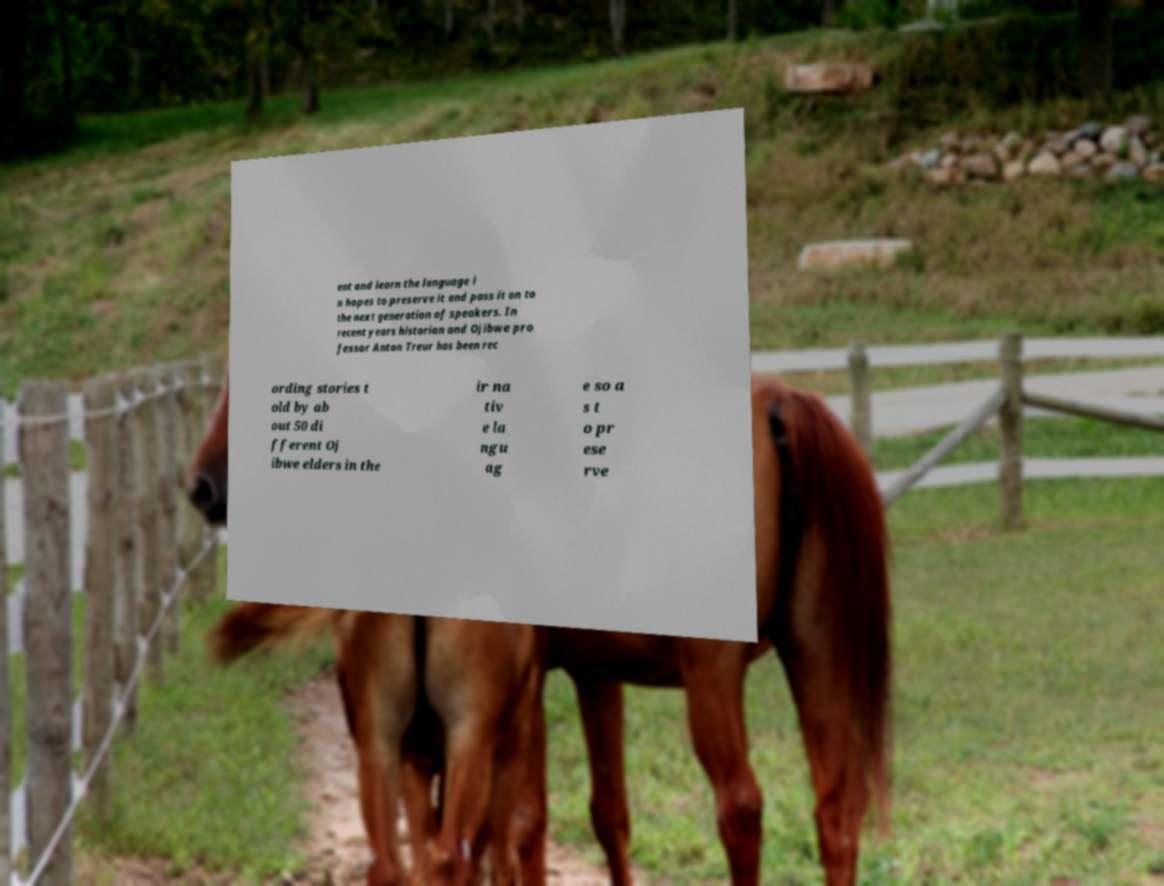Please read and relay the text visible in this image. What does it say? ent and learn the language i n hopes to preserve it and pass it on to the next generation of speakers. In recent years historian and Ojibwe pro fessor Anton Treur has been rec ording stories t old by ab out 50 di fferent Oj ibwe elders in the ir na tiv e la ngu ag e so a s t o pr ese rve 